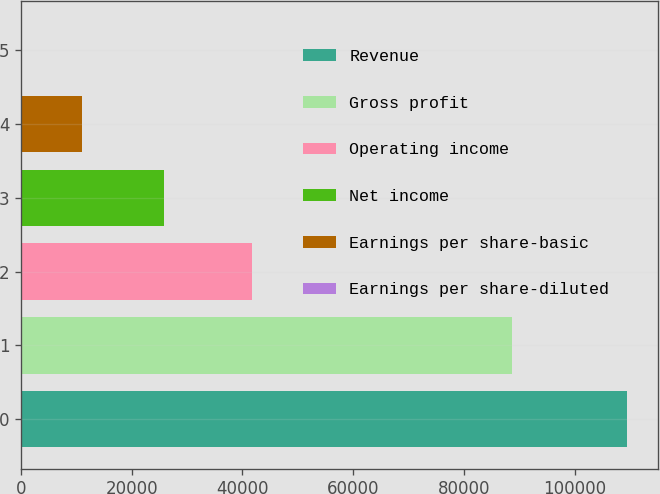<chart> <loc_0><loc_0><loc_500><loc_500><bar_chart><fcel>Revenue<fcel>Gross profit<fcel>Operating income<fcel>Net income<fcel>Earnings per share-basic<fcel>Earnings per share-diluted<nl><fcel>109545<fcel>88638<fcel>41801<fcel>25854<fcel>10954.8<fcel>0.32<nl></chart> 